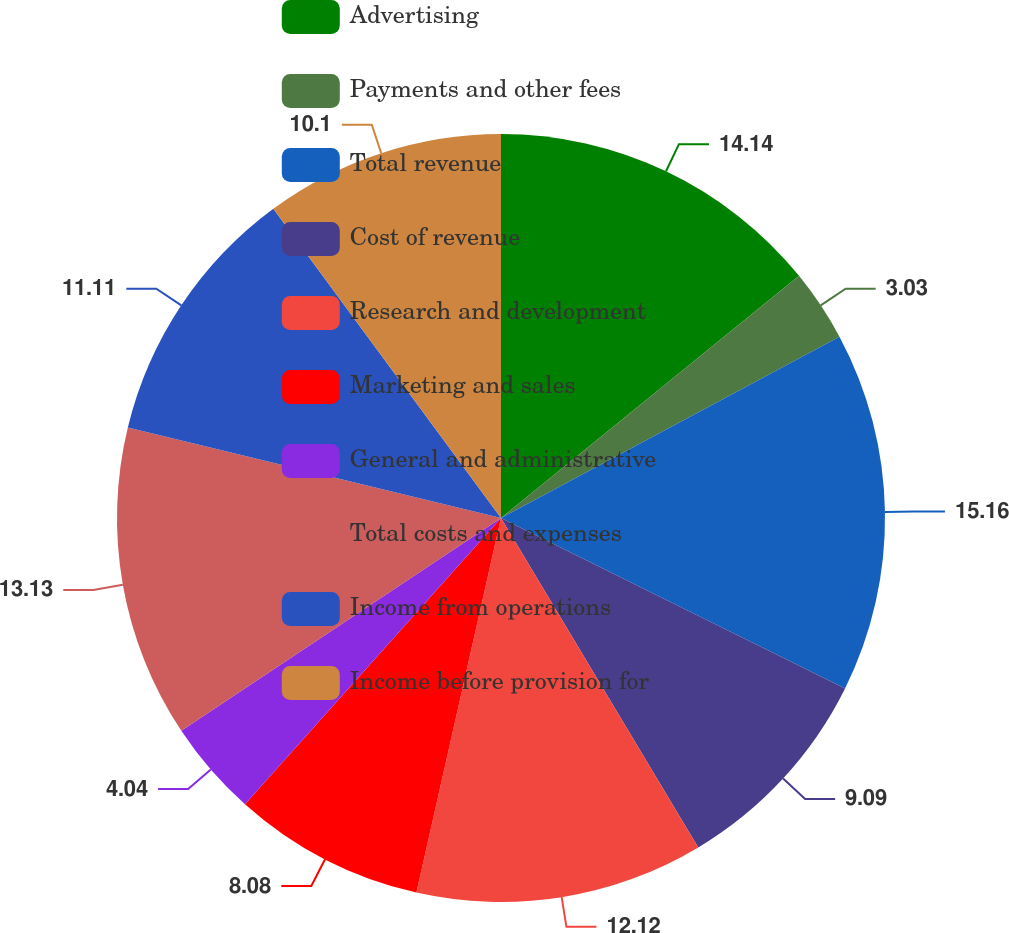Convert chart to OTSL. <chart><loc_0><loc_0><loc_500><loc_500><pie_chart><fcel>Advertising<fcel>Payments and other fees<fcel>Total revenue<fcel>Cost of revenue<fcel>Research and development<fcel>Marketing and sales<fcel>General and administrative<fcel>Total costs and expenses<fcel>Income from operations<fcel>Income before provision for<nl><fcel>14.14%<fcel>3.03%<fcel>15.15%<fcel>9.09%<fcel>12.12%<fcel>8.08%<fcel>4.04%<fcel>13.13%<fcel>11.11%<fcel>10.1%<nl></chart> 